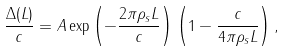Convert formula to latex. <formula><loc_0><loc_0><loc_500><loc_500>\frac { \Delta ( L ) } { c } = A \exp \left ( - \frac { 2 \pi \rho _ { s } L } { c } \right ) \left ( 1 - \frac { c } { 4 \pi \rho _ { s } L } \right ) ,</formula> 